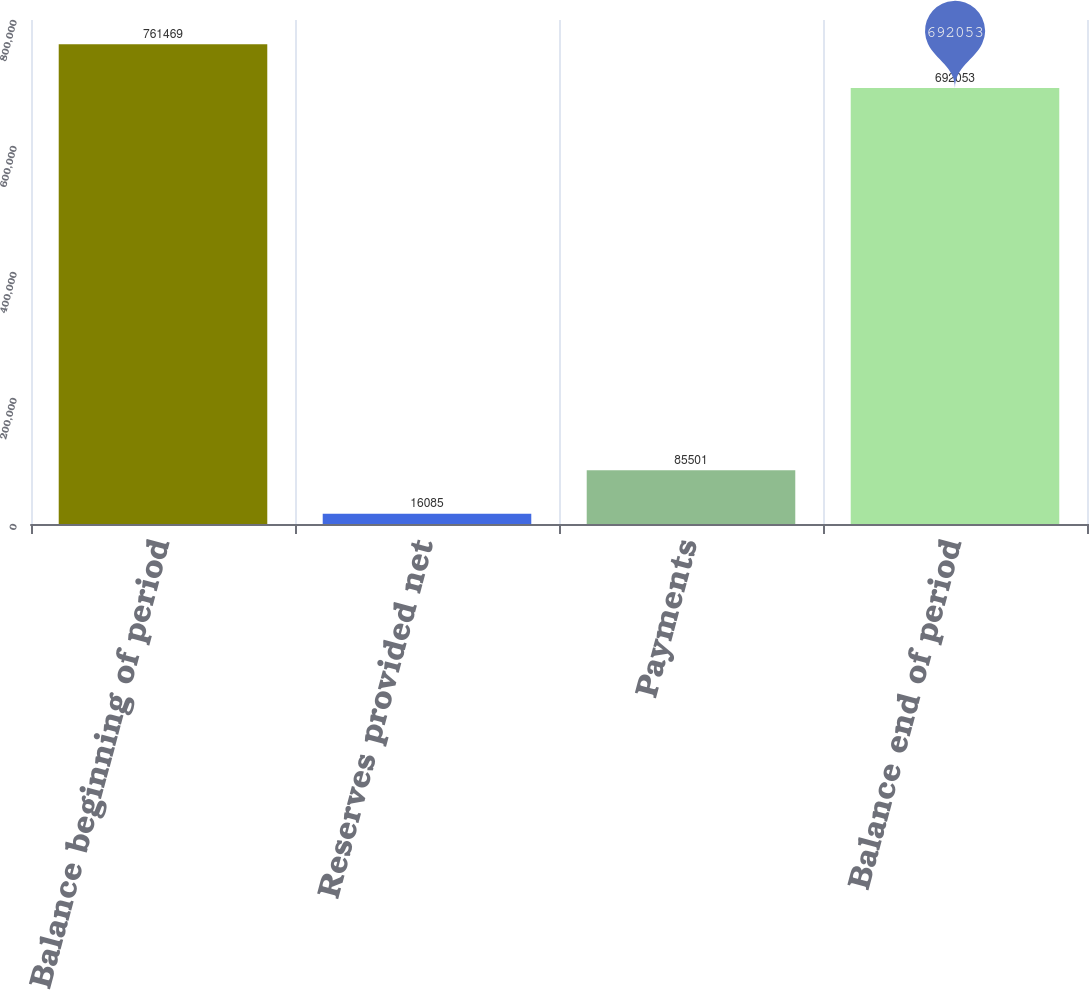Convert chart. <chart><loc_0><loc_0><loc_500><loc_500><bar_chart><fcel>Balance beginning of period<fcel>Reserves provided net<fcel>Payments<fcel>Balance end of period<nl><fcel>761469<fcel>16085<fcel>85501<fcel>692053<nl></chart> 